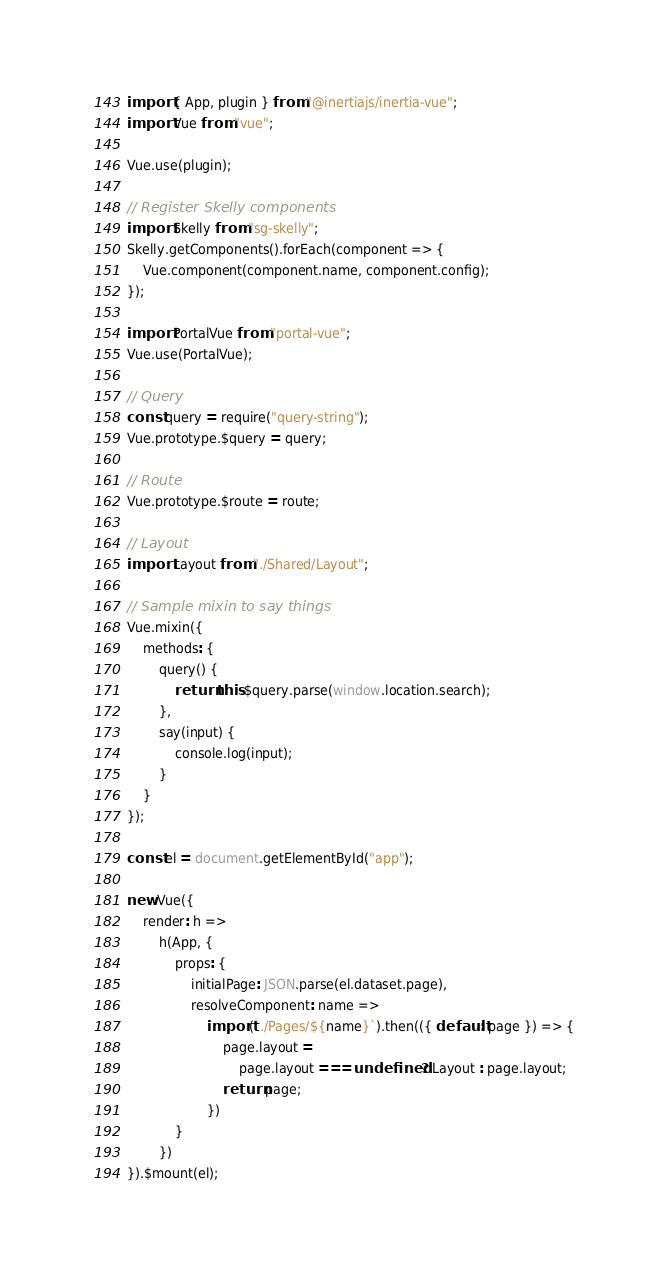Convert code to text. <code><loc_0><loc_0><loc_500><loc_500><_JavaScript_>import { App, plugin } from "@inertiajs/inertia-vue";
import Vue from "vue";

Vue.use(plugin);

// Register Skelly components
import Skelly from "sg-skelly";
Skelly.getComponents().forEach(component => {
    Vue.component(component.name, component.config);
});

import PortalVue from "portal-vue";
Vue.use(PortalVue);

// Query
const query = require("query-string");
Vue.prototype.$query = query;

// Route
Vue.prototype.$route = route;

// Layout
import Layout from "./Shared/Layout";

// Sample mixin to say things
Vue.mixin({
    methods: {
        query() {
            return this.$query.parse(window.location.search);
        },
        say(input) {
            console.log(input);
        }
    }
});

const el = document.getElementById("app");

new Vue({
    render: h =>
        h(App, {
            props: {
                initialPage: JSON.parse(el.dataset.page),
                resolveComponent: name =>
                    import(`./Pages/${name}`).then(({ default: page }) => {
                        page.layout =
                            page.layout === undefined ? Layout : page.layout;
                        return page;
                    })
            }
        })
}).$mount(el);
</code> 